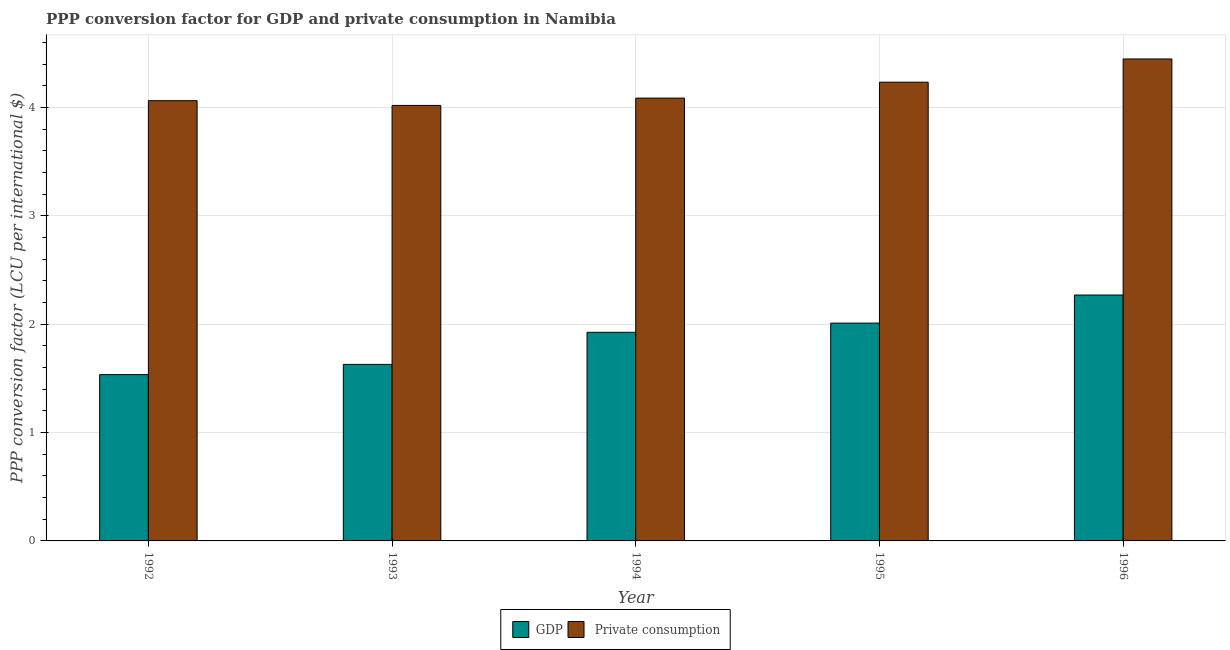How many different coloured bars are there?
Give a very brief answer. 2. Are the number of bars on each tick of the X-axis equal?
Give a very brief answer. Yes. In how many cases, is the number of bars for a given year not equal to the number of legend labels?
Ensure brevity in your answer.  0. What is the ppp conversion factor for private consumption in 1993?
Offer a terse response. 4.02. Across all years, what is the maximum ppp conversion factor for gdp?
Make the answer very short. 2.27. Across all years, what is the minimum ppp conversion factor for gdp?
Give a very brief answer. 1.53. What is the total ppp conversion factor for gdp in the graph?
Give a very brief answer. 9.37. What is the difference between the ppp conversion factor for private consumption in 1993 and that in 1995?
Your response must be concise. -0.21. What is the difference between the ppp conversion factor for gdp in 1992 and the ppp conversion factor for private consumption in 1995?
Your answer should be compact. -0.48. What is the average ppp conversion factor for private consumption per year?
Your answer should be very brief. 4.17. In how many years, is the ppp conversion factor for gdp greater than 3.8 LCU?
Provide a short and direct response. 0. What is the ratio of the ppp conversion factor for gdp in 1993 to that in 1995?
Offer a terse response. 0.81. Is the ppp conversion factor for gdp in 1994 less than that in 1996?
Offer a very short reply. Yes. Is the difference between the ppp conversion factor for gdp in 1993 and 1996 greater than the difference between the ppp conversion factor for private consumption in 1993 and 1996?
Provide a short and direct response. No. What is the difference between the highest and the second highest ppp conversion factor for gdp?
Offer a very short reply. 0.26. What is the difference between the highest and the lowest ppp conversion factor for private consumption?
Provide a short and direct response. 0.43. Is the sum of the ppp conversion factor for private consumption in 1995 and 1996 greater than the maximum ppp conversion factor for gdp across all years?
Your answer should be very brief. Yes. What does the 2nd bar from the left in 1993 represents?
Keep it short and to the point.  Private consumption. What does the 2nd bar from the right in 1996 represents?
Provide a succinct answer. GDP. How many bars are there?
Your answer should be compact. 10. Are all the bars in the graph horizontal?
Make the answer very short. No. What is the difference between two consecutive major ticks on the Y-axis?
Your response must be concise. 1. Are the values on the major ticks of Y-axis written in scientific E-notation?
Ensure brevity in your answer.  No. Does the graph contain any zero values?
Offer a terse response. No. Does the graph contain grids?
Your answer should be compact. Yes. Where does the legend appear in the graph?
Ensure brevity in your answer.  Bottom center. How many legend labels are there?
Ensure brevity in your answer.  2. How are the legend labels stacked?
Provide a succinct answer. Horizontal. What is the title of the graph?
Make the answer very short. PPP conversion factor for GDP and private consumption in Namibia. What is the label or title of the X-axis?
Offer a terse response. Year. What is the label or title of the Y-axis?
Ensure brevity in your answer.  PPP conversion factor (LCU per international $). What is the PPP conversion factor (LCU per international $) in GDP in 1992?
Your answer should be compact. 1.53. What is the PPP conversion factor (LCU per international $) of  Private consumption in 1992?
Give a very brief answer. 4.06. What is the PPP conversion factor (LCU per international $) of GDP in 1993?
Keep it short and to the point. 1.63. What is the PPP conversion factor (LCU per international $) in  Private consumption in 1993?
Your answer should be compact. 4.02. What is the PPP conversion factor (LCU per international $) of GDP in 1994?
Your answer should be very brief. 1.92. What is the PPP conversion factor (LCU per international $) of  Private consumption in 1994?
Your answer should be very brief. 4.09. What is the PPP conversion factor (LCU per international $) of GDP in 1995?
Keep it short and to the point. 2.01. What is the PPP conversion factor (LCU per international $) of  Private consumption in 1995?
Your response must be concise. 4.23. What is the PPP conversion factor (LCU per international $) in GDP in 1996?
Ensure brevity in your answer.  2.27. What is the PPP conversion factor (LCU per international $) in  Private consumption in 1996?
Provide a short and direct response. 4.45. Across all years, what is the maximum PPP conversion factor (LCU per international $) of GDP?
Your answer should be very brief. 2.27. Across all years, what is the maximum PPP conversion factor (LCU per international $) in  Private consumption?
Your answer should be very brief. 4.45. Across all years, what is the minimum PPP conversion factor (LCU per international $) of GDP?
Offer a terse response. 1.53. Across all years, what is the minimum PPP conversion factor (LCU per international $) of  Private consumption?
Make the answer very short. 4.02. What is the total PPP conversion factor (LCU per international $) of GDP in the graph?
Provide a short and direct response. 9.37. What is the total PPP conversion factor (LCU per international $) in  Private consumption in the graph?
Provide a succinct answer. 20.85. What is the difference between the PPP conversion factor (LCU per international $) of GDP in 1992 and that in 1993?
Give a very brief answer. -0.09. What is the difference between the PPP conversion factor (LCU per international $) of  Private consumption in 1992 and that in 1993?
Keep it short and to the point. 0.04. What is the difference between the PPP conversion factor (LCU per international $) of GDP in 1992 and that in 1994?
Offer a very short reply. -0.39. What is the difference between the PPP conversion factor (LCU per international $) of  Private consumption in 1992 and that in 1994?
Your response must be concise. -0.02. What is the difference between the PPP conversion factor (LCU per international $) in GDP in 1992 and that in 1995?
Make the answer very short. -0.47. What is the difference between the PPP conversion factor (LCU per international $) in  Private consumption in 1992 and that in 1995?
Offer a very short reply. -0.17. What is the difference between the PPP conversion factor (LCU per international $) of GDP in 1992 and that in 1996?
Give a very brief answer. -0.73. What is the difference between the PPP conversion factor (LCU per international $) in  Private consumption in 1992 and that in 1996?
Your response must be concise. -0.39. What is the difference between the PPP conversion factor (LCU per international $) in GDP in 1993 and that in 1994?
Make the answer very short. -0.3. What is the difference between the PPP conversion factor (LCU per international $) in  Private consumption in 1993 and that in 1994?
Offer a terse response. -0.07. What is the difference between the PPP conversion factor (LCU per international $) in GDP in 1993 and that in 1995?
Your answer should be compact. -0.38. What is the difference between the PPP conversion factor (LCU per international $) in  Private consumption in 1993 and that in 1995?
Keep it short and to the point. -0.21. What is the difference between the PPP conversion factor (LCU per international $) in GDP in 1993 and that in 1996?
Offer a terse response. -0.64. What is the difference between the PPP conversion factor (LCU per international $) of  Private consumption in 1993 and that in 1996?
Your response must be concise. -0.43. What is the difference between the PPP conversion factor (LCU per international $) in GDP in 1994 and that in 1995?
Keep it short and to the point. -0.08. What is the difference between the PPP conversion factor (LCU per international $) of  Private consumption in 1994 and that in 1995?
Provide a succinct answer. -0.15. What is the difference between the PPP conversion factor (LCU per international $) in GDP in 1994 and that in 1996?
Make the answer very short. -0.34. What is the difference between the PPP conversion factor (LCU per international $) of  Private consumption in 1994 and that in 1996?
Your response must be concise. -0.36. What is the difference between the PPP conversion factor (LCU per international $) of GDP in 1995 and that in 1996?
Offer a very short reply. -0.26. What is the difference between the PPP conversion factor (LCU per international $) in  Private consumption in 1995 and that in 1996?
Your answer should be compact. -0.21. What is the difference between the PPP conversion factor (LCU per international $) in GDP in 1992 and the PPP conversion factor (LCU per international $) in  Private consumption in 1993?
Make the answer very short. -2.48. What is the difference between the PPP conversion factor (LCU per international $) in GDP in 1992 and the PPP conversion factor (LCU per international $) in  Private consumption in 1994?
Make the answer very short. -2.55. What is the difference between the PPP conversion factor (LCU per international $) in GDP in 1992 and the PPP conversion factor (LCU per international $) in  Private consumption in 1995?
Keep it short and to the point. -2.7. What is the difference between the PPP conversion factor (LCU per international $) of GDP in 1992 and the PPP conversion factor (LCU per international $) of  Private consumption in 1996?
Offer a very short reply. -2.91. What is the difference between the PPP conversion factor (LCU per international $) in GDP in 1993 and the PPP conversion factor (LCU per international $) in  Private consumption in 1994?
Give a very brief answer. -2.46. What is the difference between the PPP conversion factor (LCU per international $) in GDP in 1993 and the PPP conversion factor (LCU per international $) in  Private consumption in 1995?
Make the answer very short. -2.6. What is the difference between the PPP conversion factor (LCU per international $) in GDP in 1993 and the PPP conversion factor (LCU per international $) in  Private consumption in 1996?
Your answer should be very brief. -2.82. What is the difference between the PPP conversion factor (LCU per international $) in GDP in 1994 and the PPP conversion factor (LCU per international $) in  Private consumption in 1995?
Ensure brevity in your answer.  -2.31. What is the difference between the PPP conversion factor (LCU per international $) of GDP in 1994 and the PPP conversion factor (LCU per international $) of  Private consumption in 1996?
Offer a very short reply. -2.52. What is the difference between the PPP conversion factor (LCU per international $) in GDP in 1995 and the PPP conversion factor (LCU per international $) in  Private consumption in 1996?
Offer a very short reply. -2.44. What is the average PPP conversion factor (LCU per international $) of GDP per year?
Your response must be concise. 1.87. What is the average PPP conversion factor (LCU per international $) of  Private consumption per year?
Your answer should be very brief. 4.17. In the year 1992, what is the difference between the PPP conversion factor (LCU per international $) in GDP and PPP conversion factor (LCU per international $) in  Private consumption?
Provide a succinct answer. -2.53. In the year 1993, what is the difference between the PPP conversion factor (LCU per international $) of GDP and PPP conversion factor (LCU per international $) of  Private consumption?
Ensure brevity in your answer.  -2.39. In the year 1994, what is the difference between the PPP conversion factor (LCU per international $) in GDP and PPP conversion factor (LCU per international $) in  Private consumption?
Give a very brief answer. -2.16. In the year 1995, what is the difference between the PPP conversion factor (LCU per international $) in GDP and PPP conversion factor (LCU per international $) in  Private consumption?
Your answer should be very brief. -2.22. In the year 1996, what is the difference between the PPP conversion factor (LCU per international $) in GDP and PPP conversion factor (LCU per international $) in  Private consumption?
Ensure brevity in your answer.  -2.18. What is the ratio of the PPP conversion factor (LCU per international $) in GDP in 1992 to that in 1993?
Your answer should be very brief. 0.94. What is the ratio of the PPP conversion factor (LCU per international $) of  Private consumption in 1992 to that in 1993?
Keep it short and to the point. 1.01. What is the ratio of the PPP conversion factor (LCU per international $) of GDP in 1992 to that in 1994?
Your response must be concise. 0.8. What is the ratio of the PPP conversion factor (LCU per international $) of  Private consumption in 1992 to that in 1994?
Make the answer very short. 0.99. What is the ratio of the PPP conversion factor (LCU per international $) in GDP in 1992 to that in 1995?
Ensure brevity in your answer.  0.76. What is the ratio of the PPP conversion factor (LCU per international $) in  Private consumption in 1992 to that in 1995?
Offer a terse response. 0.96. What is the ratio of the PPP conversion factor (LCU per international $) in GDP in 1992 to that in 1996?
Your response must be concise. 0.68. What is the ratio of the PPP conversion factor (LCU per international $) in  Private consumption in 1992 to that in 1996?
Give a very brief answer. 0.91. What is the ratio of the PPP conversion factor (LCU per international $) in GDP in 1993 to that in 1994?
Ensure brevity in your answer.  0.85. What is the ratio of the PPP conversion factor (LCU per international $) in  Private consumption in 1993 to that in 1994?
Your answer should be compact. 0.98. What is the ratio of the PPP conversion factor (LCU per international $) in GDP in 1993 to that in 1995?
Offer a terse response. 0.81. What is the ratio of the PPP conversion factor (LCU per international $) in  Private consumption in 1993 to that in 1995?
Your response must be concise. 0.95. What is the ratio of the PPP conversion factor (LCU per international $) in GDP in 1993 to that in 1996?
Your answer should be compact. 0.72. What is the ratio of the PPP conversion factor (LCU per international $) of  Private consumption in 1993 to that in 1996?
Your answer should be very brief. 0.9. What is the ratio of the PPP conversion factor (LCU per international $) in GDP in 1994 to that in 1995?
Ensure brevity in your answer.  0.96. What is the ratio of the PPP conversion factor (LCU per international $) in  Private consumption in 1994 to that in 1995?
Make the answer very short. 0.97. What is the ratio of the PPP conversion factor (LCU per international $) in GDP in 1994 to that in 1996?
Offer a very short reply. 0.85. What is the ratio of the PPP conversion factor (LCU per international $) of  Private consumption in 1994 to that in 1996?
Keep it short and to the point. 0.92. What is the ratio of the PPP conversion factor (LCU per international $) of GDP in 1995 to that in 1996?
Give a very brief answer. 0.89. What is the ratio of the PPP conversion factor (LCU per international $) of  Private consumption in 1995 to that in 1996?
Ensure brevity in your answer.  0.95. What is the difference between the highest and the second highest PPP conversion factor (LCU per international $) in GDP?
Make the answer very short. 0.26. What is the difference between the highest and the second highest PPP conversion factor (LCU per international $) in  Private consumption?
Provide a short and direct response. 0.21. What is the difference between the highest and the lowest PPP conversion factor (LCU per international $) in GDP?
Offer a terse response. 0.73. What is the difference between the highest and the lowest PPP conversion factor (LCU per international $) of  Private consumption?
Keep it short and to the point. 0.43. 